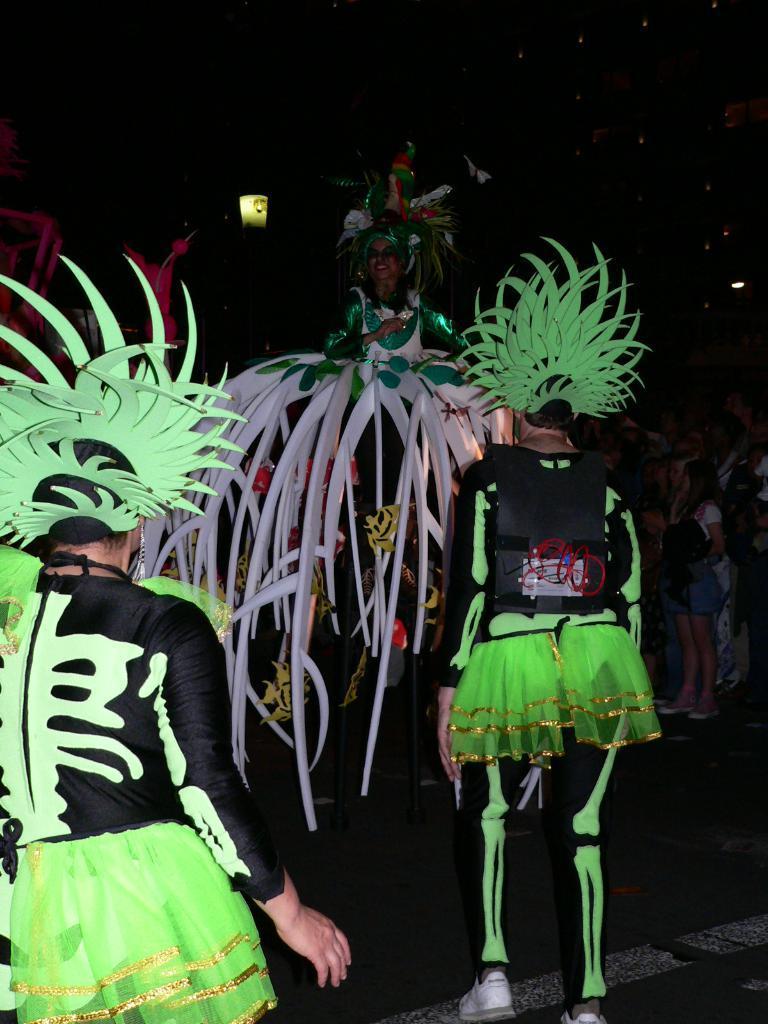How would you summarize this image in a sentence or two? As we can see in the image there are few people here and there wearing green and black color dresses. The image is little dark. 